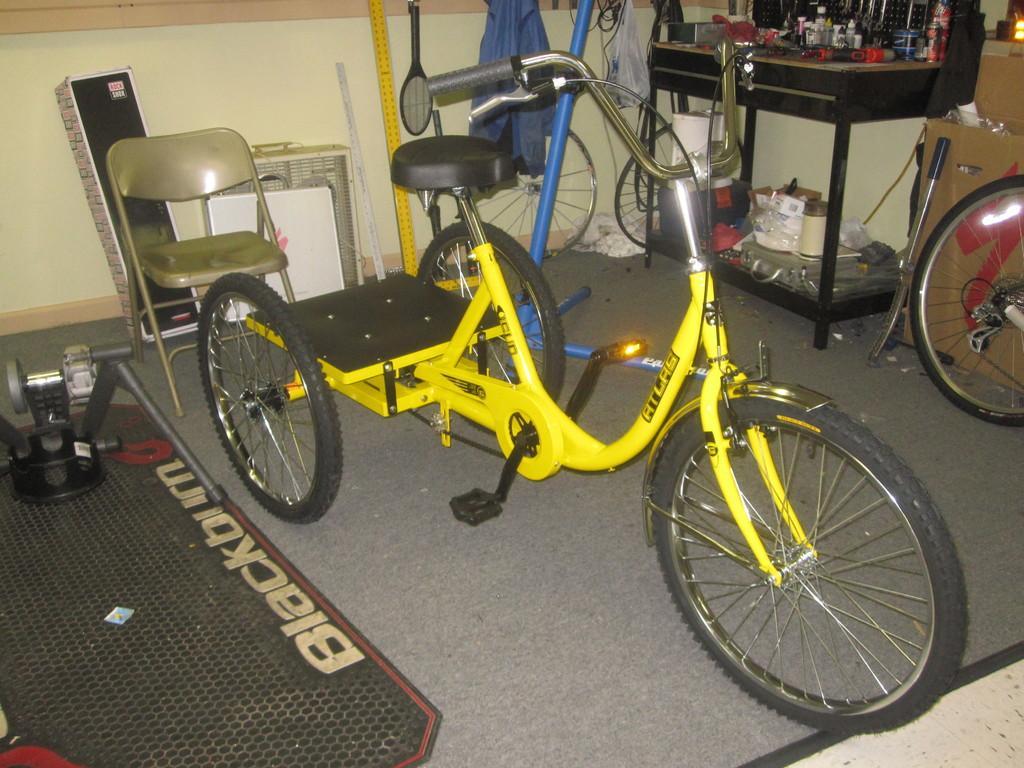In one or two sentences, can you explain what this image depicts? In the image we can see a bicycle, yellow and black in color. There is even a chair. Here we can see a bat, table and on the table there are objects and a carton box. Here we can see a wheel, carpet, whiteboard, stick, cable wires and a floor. 